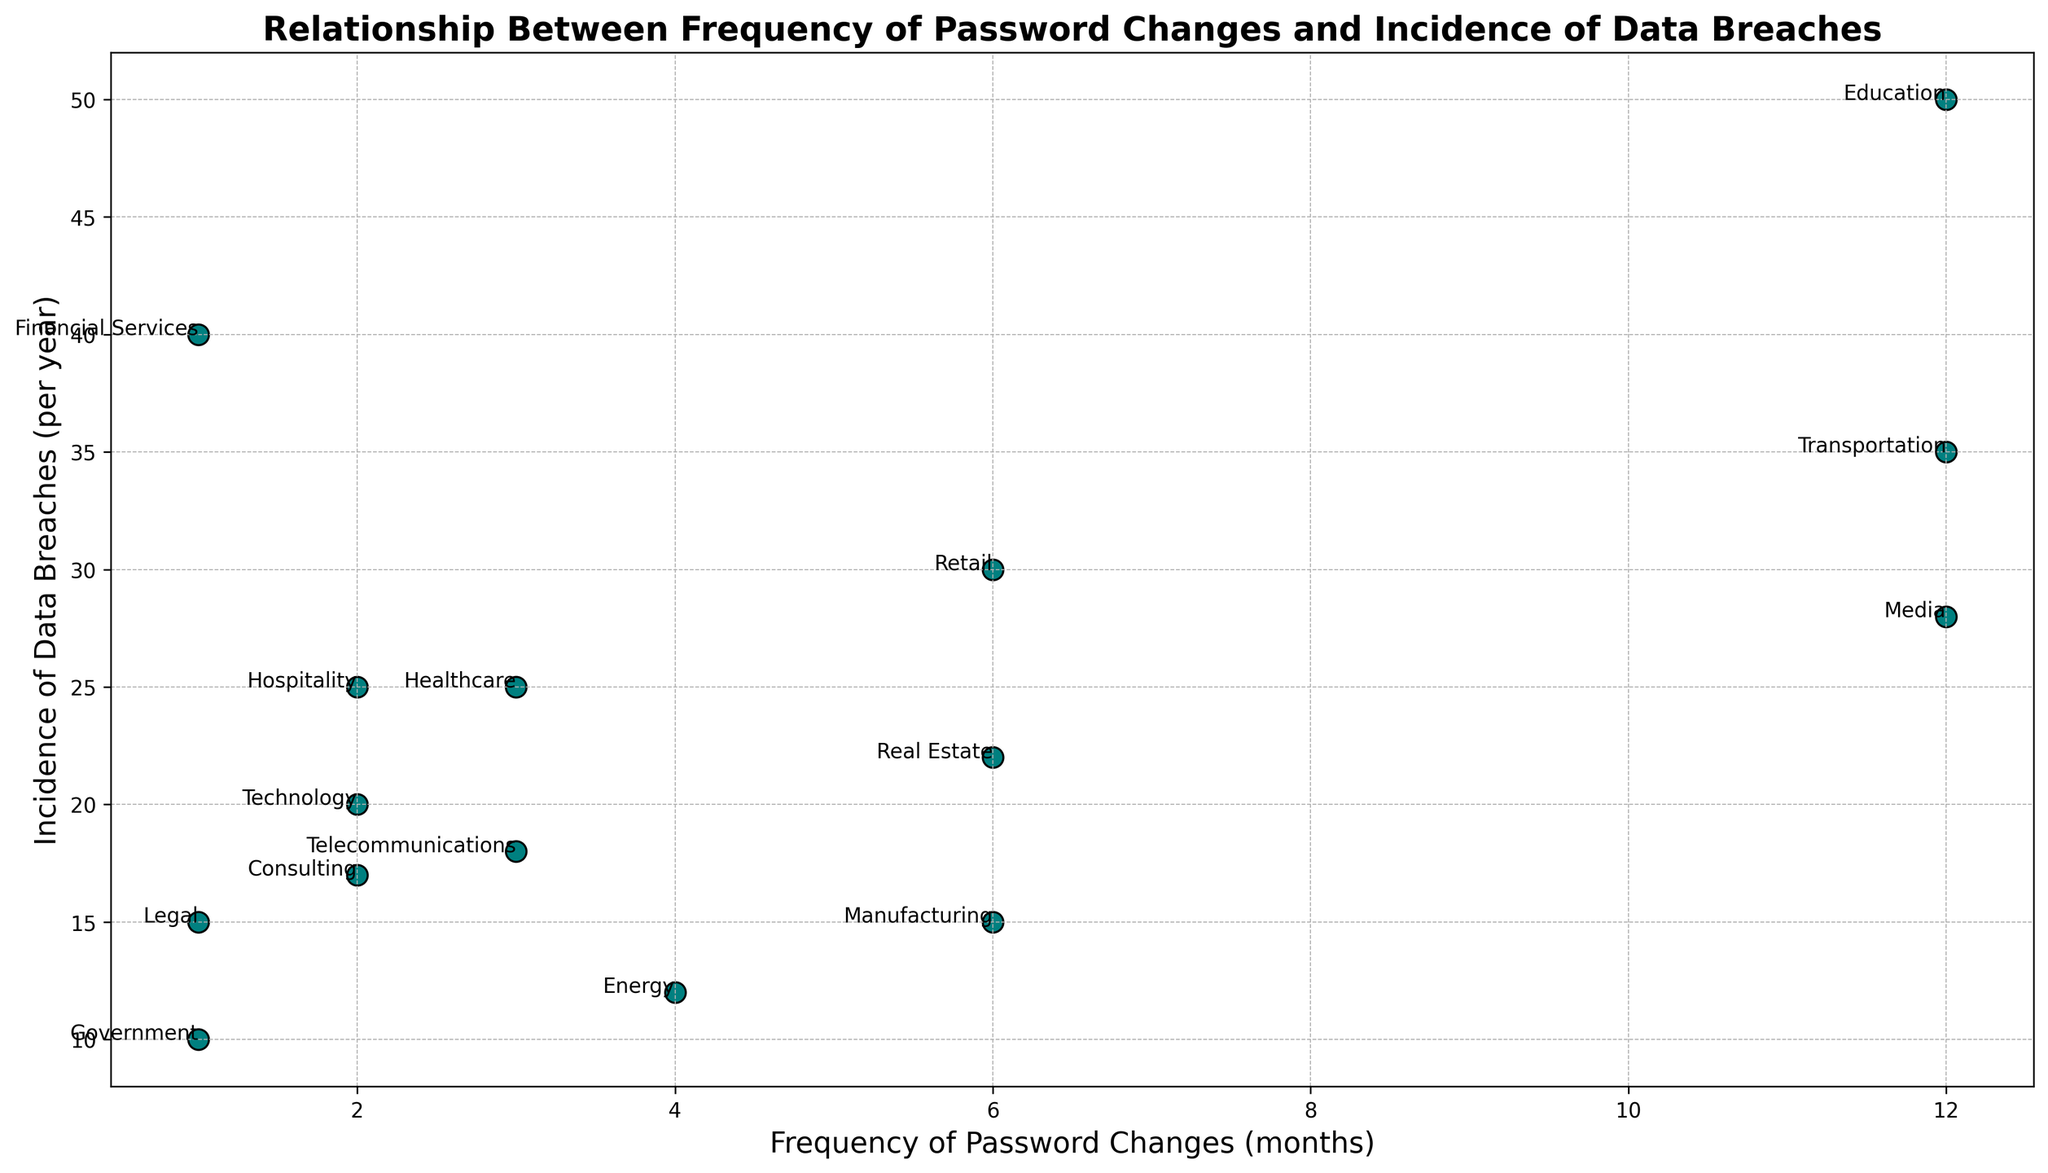What industry shows the highest incidence of data breaches? In the scatter plot, the industry with the highest y-axis value corresponds to the highest incidence of data breaches. The Education industry, located at (12, 50), has the highest data breach incidence.
Answer: Education Which industry changes their passwords most frequently and what is the corresponding incidence of data breaches? The industry at the minimum x-axis value changes their passwords most frequently. The Financial Services and Government industries are at x=1. Their corresponding data breach incidences are 40 and 10, respectively.
Answer: Financial Services and Government, 40 and 10 Compare the incidence of data breaches between the Healthcare and Technology industries. Which one has more breaches and by how much? Locate the Healthcare industry at (3, 25) and the Technology industry at (2, 20). Subtract the breach incidences: 25 - 20 = 5.
Answer: Healthcare, 5 What's the average frequency of password changes for industries with an incidence of data breaches below 20 per year? First, identify the relevant industries: Technology (2, 20), Manufacturing (6, 15), Government (1, 10), Telecommunications (3, 18), Energy (4, 12), Legal (1, 15), and Consulting (2, 17). Sum and count their frequencies: (2 + 6 + 1 + 3 + 4 + 1 + 2) = 19 months. There are 7 industries, so the average is 19/7 ≈ 2.7 months.
Answer: 2.7 months Is there any industry with both a high frequency of password changes (greater than 6 months) and a high incidence of data breaches (greater than 30 per year)? Check all points where x > 6 and y > 30. The Education (12, 50) and Transportation (12, 35) industries have both conditions satisfied, with Education and Transportation being the only industries meeting these criteria.
Answer: Education and Transportation What is the range of the frequency of password changes among the industries shown in the plot? Identify the minimum and maximum x-axis values from the scatter plot. The minimum frequency of password changes is 1 month (Financial Services, Government, Legal) and the maximum is 12 months (Education, Transportation, Media). The range is 12 - 1 = 11 months.
Answer: 11 months Which industry has the lowest incidence of data breaches and how often do they change passwords? The industry at the minimum y-axis value has the lowest incidence. The Government industry located at (1, 10) has the lowest data breach incidence of 10. They change passwords every month.
Answer: Government, 1 month 